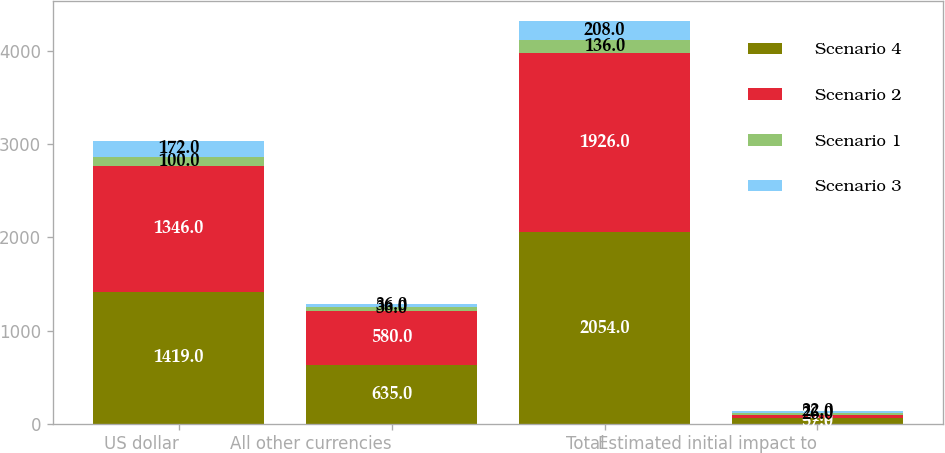<chart> <loc_0><loc_0><loc_500><loc_500><stacked_bar_chart><ecel><fcel>US dollar<fcel>All other currencies<fcel>Total<fcel>Estimated initial impact to<nl><fcel>Scenario 4<fcel>1419<fcel>635<fcel>2054<fcel>57<nl><fcel>Scenario 2<fcel>1346<fcel>580<fcel>1926<fcel>34<nl><fcel>Scenario 1<fcel>100<fcel>36<fcel>136<fcel>26<nl><fcel>Scenario 3<fcel>172<fcel>36<fcel>208<fcel>22<nl></chart> 